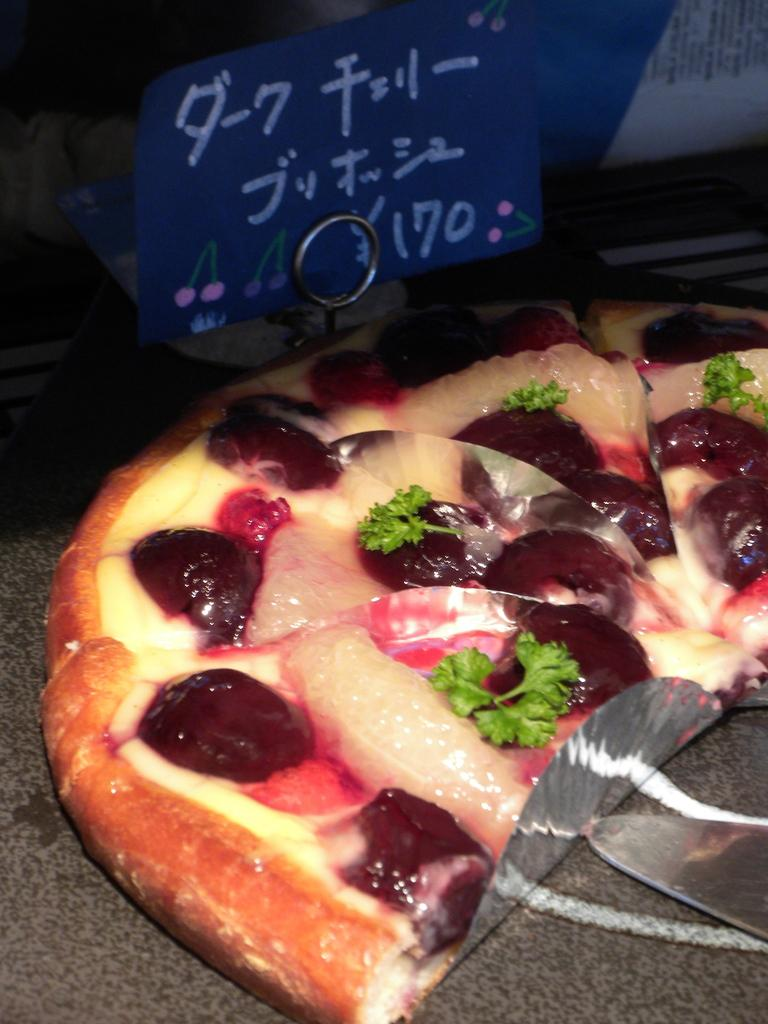What types of establishments are shown in the image? There are food places in the image. Can you identify any specific details about the food places? Unfortunately, the provided facts do not give any specific details about the food places. What additional information can be gathered from the image? There is a price tag visible in the image. What type of cord is used to connect the ink to the food places in the image? There is no cord or ink present in the image; it only features food places and a price tag. 